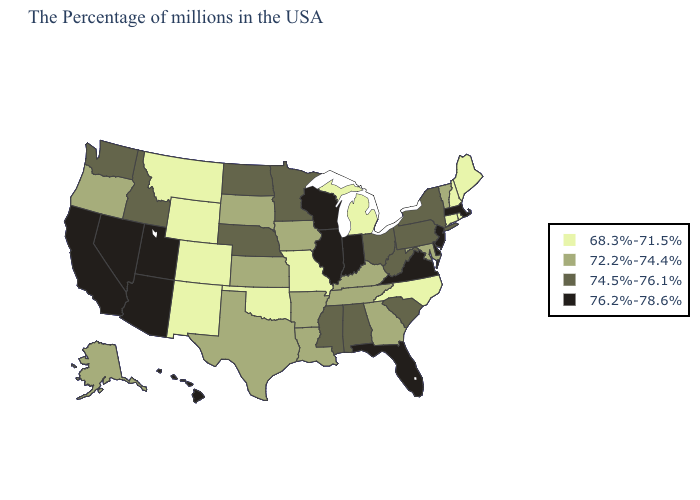Name the states that have a value in the range 72.2%-74.4%?
Quick response, please. Vermont, Maryland, Georgia, Kentucky, Tennessee, Louisiana, Arkansas, Iowa, Kansas, Texas, South Dakota, Oregon, Alaska. Which states have the lowest value in the USA?
Give a very brief answer. Maine, Rhode Island, New Hampshire, Connecticut, North Carolina, Michigan, Missouri, Oklahoma, Wyoming, Colorado, New Mexico, Montana. Does New Hampshire have the lowest value in the USA?
Give a very brief answer. Yes. Does West Virginia have the highest value in the South?
Be succinct. No. Does Nevada have the highest value in the USA?
Quick response, please. Yes. Name the states that have a value in the range 68.3%-71.5%?
Quick response, please. Maine, Rhode Island, New Hampshire, Connecticut, North Carolina, Michigan, Missouri, Oklahoma, Wyoming, Colorado, New Mexico, Montana. Name the states that have a value in the range 74.5%-76.1%?
Be succinct. New York, Pennsylvania, South Carolina, West Virginia, Ohio, Alabama, Mississippi, Minnesota, Nebraska, North Dakota, Idaho, Washington. Does Ohio have the lowest value in the USA?
Write a very short answer. No. Name the states that have a value in the range 74.5%-76.1%?
Give a very brief answer. New York, Pennsylvania, South Carolina, West Virginia, Ohio, Alabama, Mississippi, Minnesota, Nebraska, North Dakota, Idaho, Washington. Name the states that have a value in the range 76.2%-78.6%?
Answer briefly. Massachusetts, New Jersey, Delaware, Virginia, Florida, Indiana, Wisconsin, Illinois, Utah, Arizona, Nevada, California, Hawaii. Does Vermont have the highest value in the USA?
Answer briefly. No. Does Minnesota have a higher value than Washington?
Write a very short answer. No. What is the lowest value in the USA?
Keep it brief. 68.3%-71.5%. Name the states that have a value in the range 72.2%-74.4%?
Answer briefly. Vermont, Maryland, Georgia, Kentucky, Tennessee, Louisiana, Arkansas, Iowa, Kansas, Texas, South Dakota, Oregon, Alaska. What is the lowest value in states that border Washington?
Give a very brief answer. 72.2%-74.4%. 